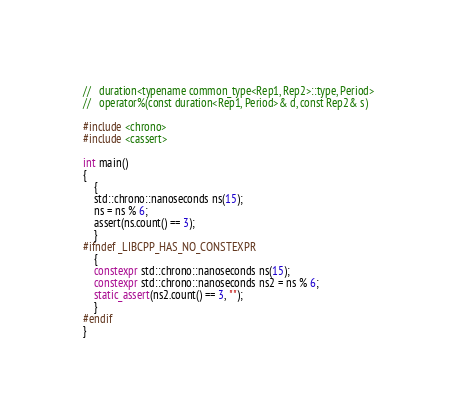<code> <loc_0><loc_0><loc_500><loc_500><_C++_>//   duration<typename common_type<Rep1, Rep2>::type, Period>
//   operator%(const duration<Rep1, Period>& d, const Rep2& s)

#include <chrono>
#include <cassert>

int main()
{
    {
    std::chrono::nanoseconds ns(15);
    ns = ns % 6;
    assert(ns.count() == 3);
    }
#ifndef _LIBCPP_HAS_NO_CONSTEXPR
    {
    constexpr std::chrono::nanoseconds ns(15);
    constexpr std::chrono::nanoseconds ns2 = ns % 6;
    static_assert(ns2.count() == 3, "");
    }
#endif
}
</code> 